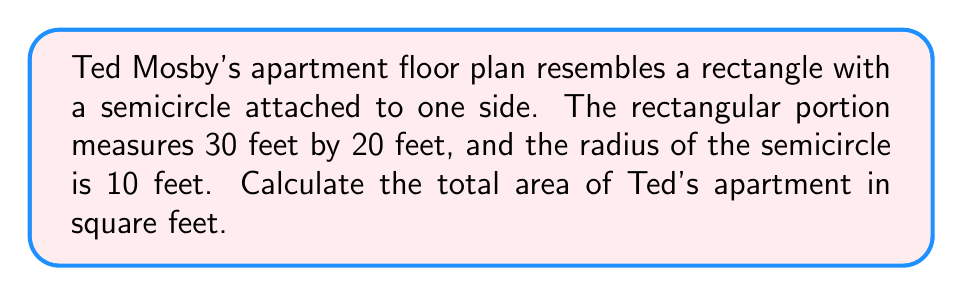What is the answer to this math problem? Let's break this down step-by-step:

1. Calculate the area of the rectangular portion:
   $$A_{rectangle} = l \times w = 30 \text{ ft} \times 20 \text{ ft} = 600 \text{ sq ft}$$

2. Calculate the area of the semicircle:
   $$A_{semicircle} = \frac{1}{2} \times \pi r^2 = \frac{1}{2} \times \pi \times (10 \text{ ft})^2 = 50\pi \text{ sq ft}$$

3. Sum up the areas:
   $$A_{total} = A_{rectangle} + A_{semicircle} = 600 \text{ sq ft} + 50\pi \text{ sq ft}$$

4. Simplify:
   $$A_{total} = (600 + 50\pi) \text{ sq ft} \approx 757.08 \text{ sq ft}$$

[asy]
import geometry;

draw((0,0)--(30,0)--(30,20)--(0,20)--cycle);
draw(arc((30,10),10,90,270));
label("30 ft",(15,0),S);
label("20 ft",(0,10),W);
label("r = 10 ft",(30,10),E);
[/asy]
Answer: $(600 + 50\pi)$ sq ft $\approx 757.08$ sq ft 